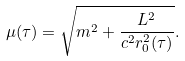Convert formula to latex. <formula><loc_0><loc_0><loc_500><loc_500>\mu ( \tau ) = \sqrt { m ^ { 2 } + \frac { L ^ { 2 } } { c ^ { 2 } r _ { 0 } ^ { 2 } ( \tau ) } } .</formula> 